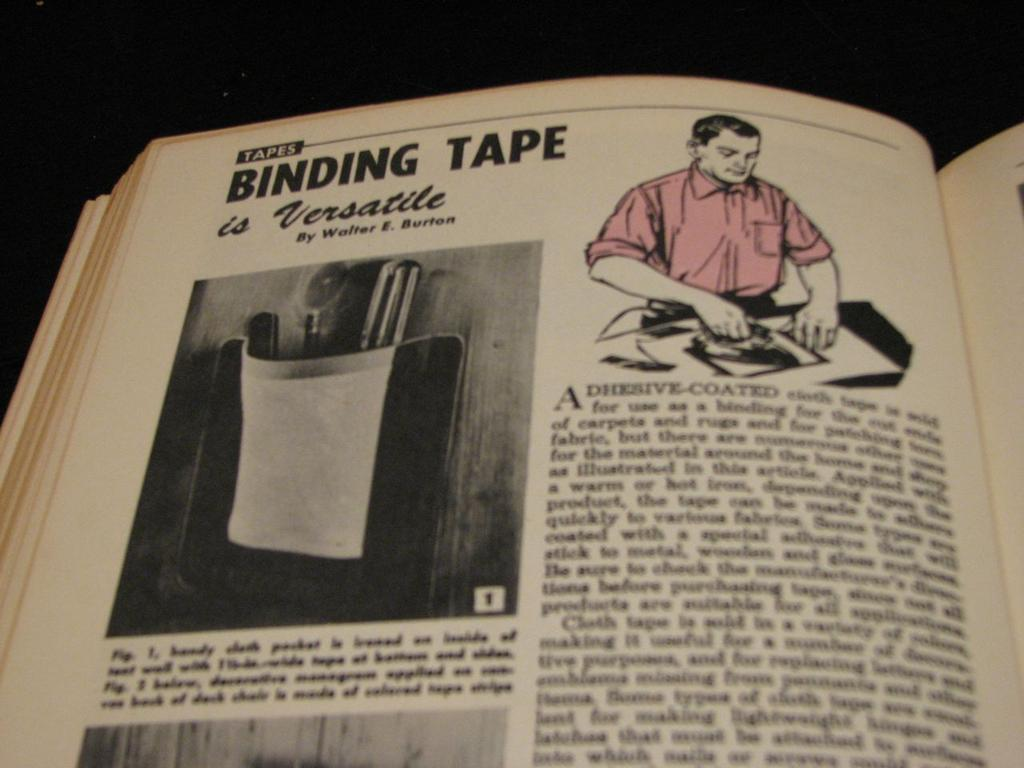<image>
Relay a brief, clear account of the picture shown. Vintage book opened to Tapes Binding Tape is Versatile with a photo and an illustration of a man using tape. 